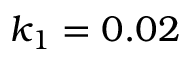<formula> <loc_0><loc_0><loc_500><loc_500>k _ { 1 } = 0 . 0 2</formula> 